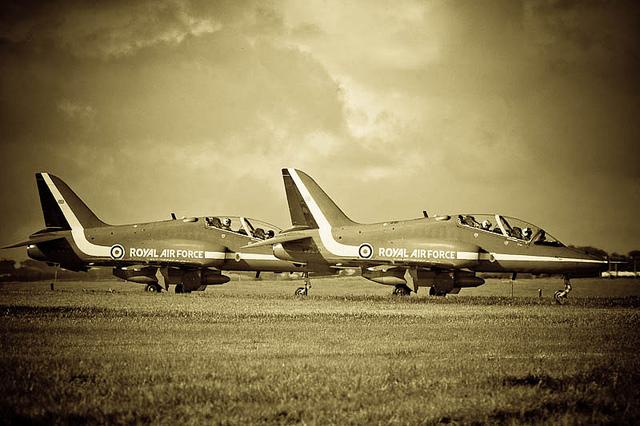How many planes are here?
Keep it brief. 2. Where was this photograph taken?
Answer briefly. Air force base. What does it say on the side of the plane?
Concise answer only. Royal air force. 